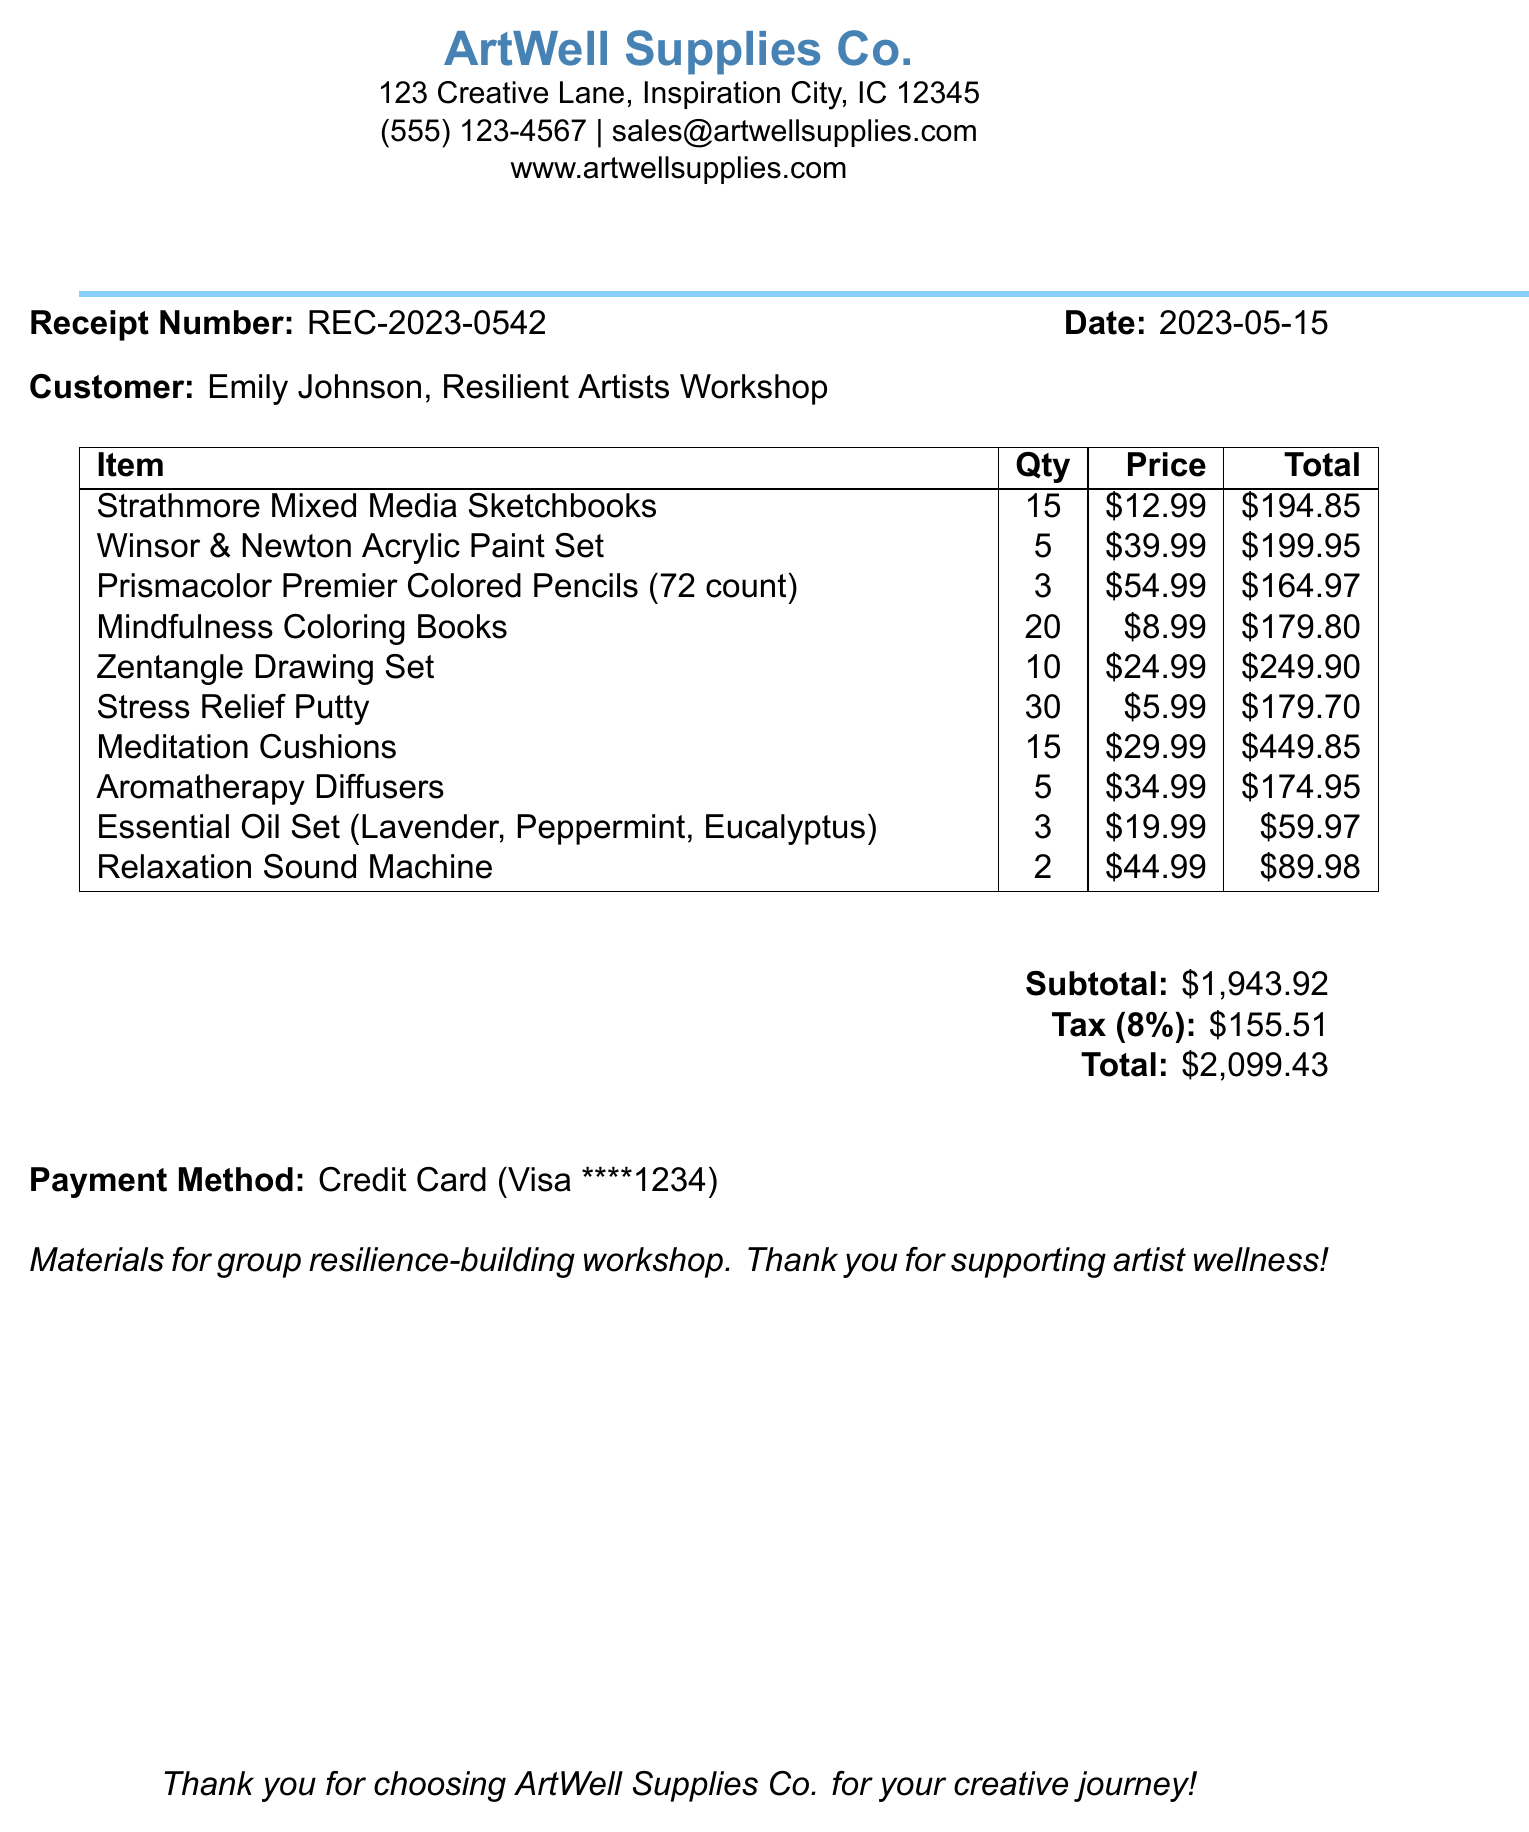What is the business name? The business name is listed at the top of the document under the company logo.
Answer: ArtWell Supplies Co What is the receipt number? The receipt number is mentioned in the document for reference.
Answer: REC-2023-0542 How many Strathmore Mixed Media Sketchbooks were purchased? The quantity of each item is specified in the item's listing within the document.
Answer: 15 What is the total amount spent on the Winsor & Newton Acrylic Paint Set? The total for each item is clearly stated in the table of items.
Answer: $199.95 What is the subtotal before tax? The subtotal is calculated as the sum of all item totals before tax is added.
Answer: $1,943.92 How much tax was applied to the purchase? The tax amount is indicated in the calculations section of the document.
Answer: $155.51 What type of payment was used? Payment method details can be found towards the end of the receipt.
Answer: Credit Card What was the total amount of the purchase? The total amount reflects the combined total of the subtotal and tax.
Answer: $2,099.43 How many Meditation Cushions were bought? The number of items purchased is recorded in the item list.
Answer: 15 